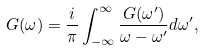Convert formula to latex. <formula><loc_0><loc_0><loc_500><loc_500>G ( \omega ) = \frac { i } { \pi } \int _ { - \infty } ^ { \infty } \frac { G ( \omega ^ { \prime } ) } { \omega - \omega ^ { \prime } } d \omega ^ { \prime } ,</formula> 